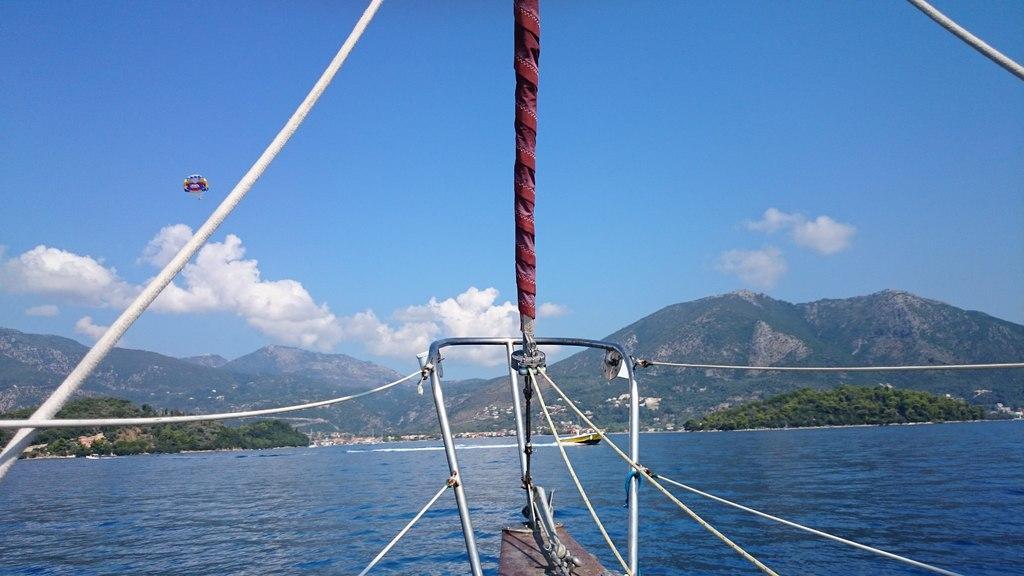In one or two sentences, can you explain what this image depicts? In this image there is the sky towards the top of the image, there are clouds in the sky, there are mountains, there are trees, there is water towards the bottom of the image, there is a boat on the water, there are ropes towards the top of the image, there is an object towards the bottom of the image. 